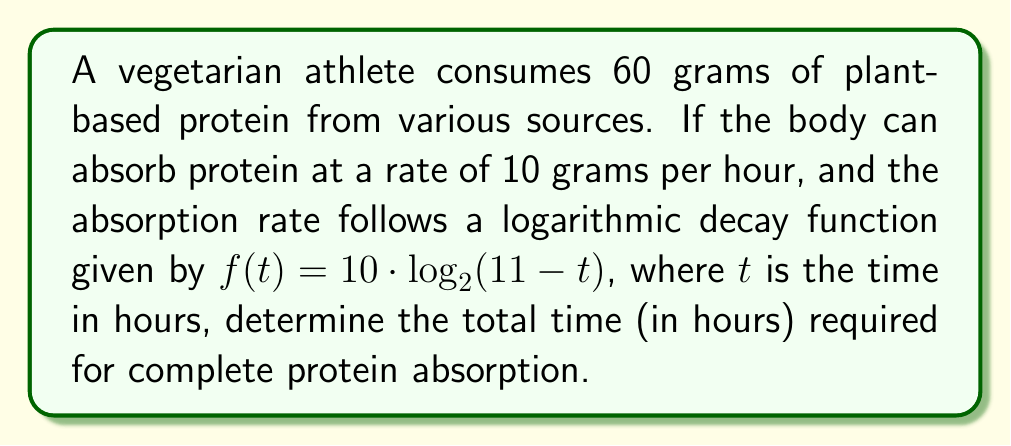Give your solution to this math problem. 1. The total amount of protein to be absorbed is 60 grams.

2. The absorption rate function is given by:
   $f(t) = 10 \cdot \log_2(11-t)$

3. To find the total time, we need to integrate the absorption rate function from 0 to the unknown time T:
   $$\int_0^T 10 \cdot \log_2(11-t) \, dt = 60$$

4. Let's solve this integral:
   $$10 \cdot \left[(11-t)\log_2(11-t) - \frac{11-t}{\ln(2)}\right]_0^T = 60$$

5. Evaluating the integral:
   $$10 \cdot \left[(11-T)\log_2(11-T) - \frac{11-T}{\ln(2)} - 11\log_2(11) + \frac{11}{\ln(2)}\right] = 60$$

6. Simplifying:
   $$110\log_2(11) - (11-T)\log_2(11-T) - \frac{T}{\ln(2)} = 6$$

7. This equation cannot be solved analytically. We need to use numerical methods to find T.

8. Using a numerical solver (e.g., Newton-Raphson method), we find:
   $T \approx 9.32$ hours

Therefore, it takes approximately 9.32 hours for complete protein absorption.
Answer: 9.32 hours 